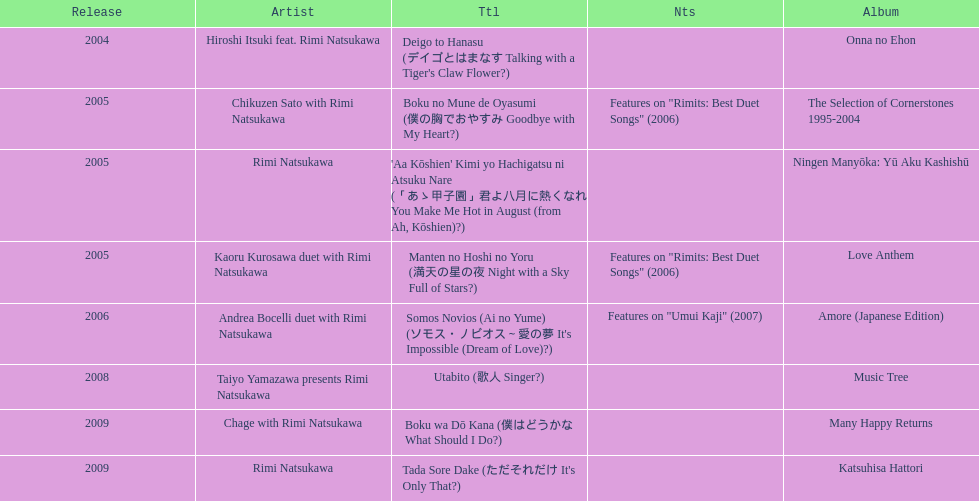What are all of the titles? Deigo to Hanasu (デイゴとはまなす Talking with a Tiger's Claw Flower?), Boku no Mune de Oyasumi (僕の胸でおやすみ Goodbye with My Heart?), 'Aa Kōshien' Kimi yo Hachigatsu ni Atsuku Nare (「あゝ甲子園」君よ八月に熱くなれ You Make Me Hot in August (from Ah, Kōshien)?), Manten no Hoshi no Yoru (満天の星の夜 Night with a Sky Full of Stars?), Somos Novios (Ai no Yume) (ソモス・ノビオス～愛の夢 It's Impossible (Dream of Love)?), Utabito (歌人 Singer?), Boku wa Dō Kana (僕はどうかな What Should I Do?), Tada Sore Dake (ただそれだけ It's Only That?). What are their notes? , Features on "Rimits: Best Duet Songs" (2006), , Features on "Rimits: Best Duet Songs" (2006), Features on "Umui Kaji" (2007), , , . Which title shares its notes with manten no hoshi no yoru (man tian noxing noye night with a sky full of stars?)? Boku no Mune de Oyasumi (僕の胸でおやすみ Goodbye with My Heart?). 